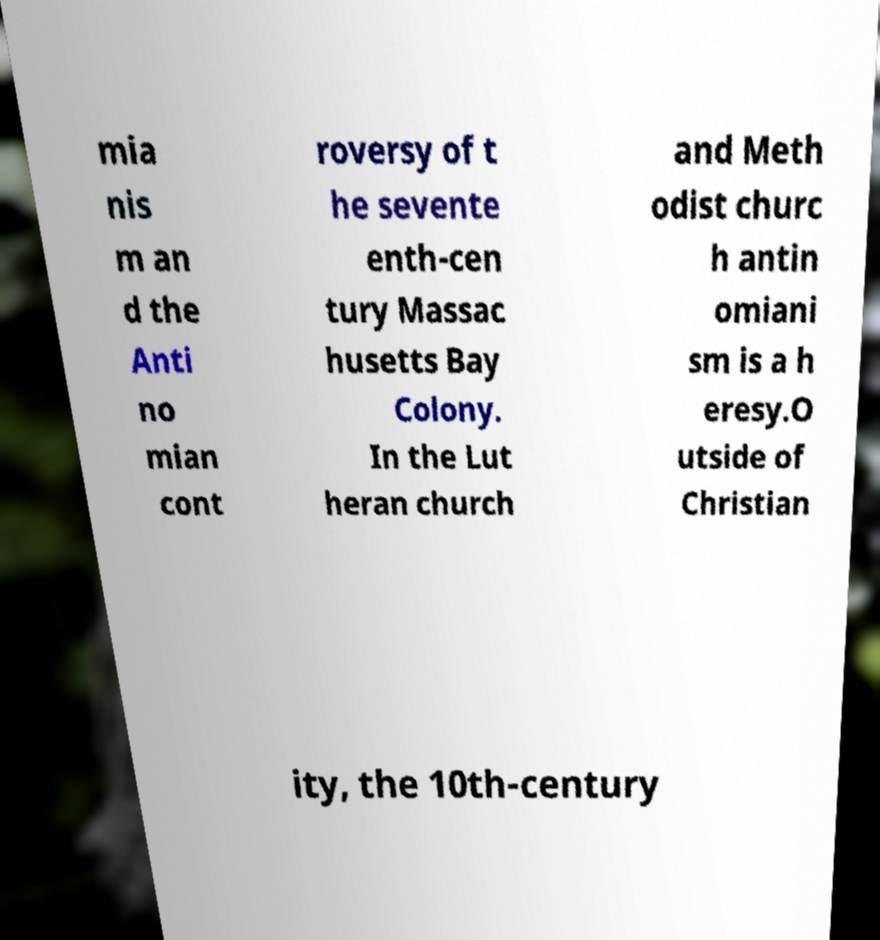Could you assist in decoding the text presented in this image and type it out clearly? mia nis m an d the Anti no mian cont roversy of t he sevente enth-cen tury Massac husetts Bay Colony. In the Lut heran church and Meth odist churc h antin omiani sm is a h eresy.O utside of Christian ity, the 10th-century 